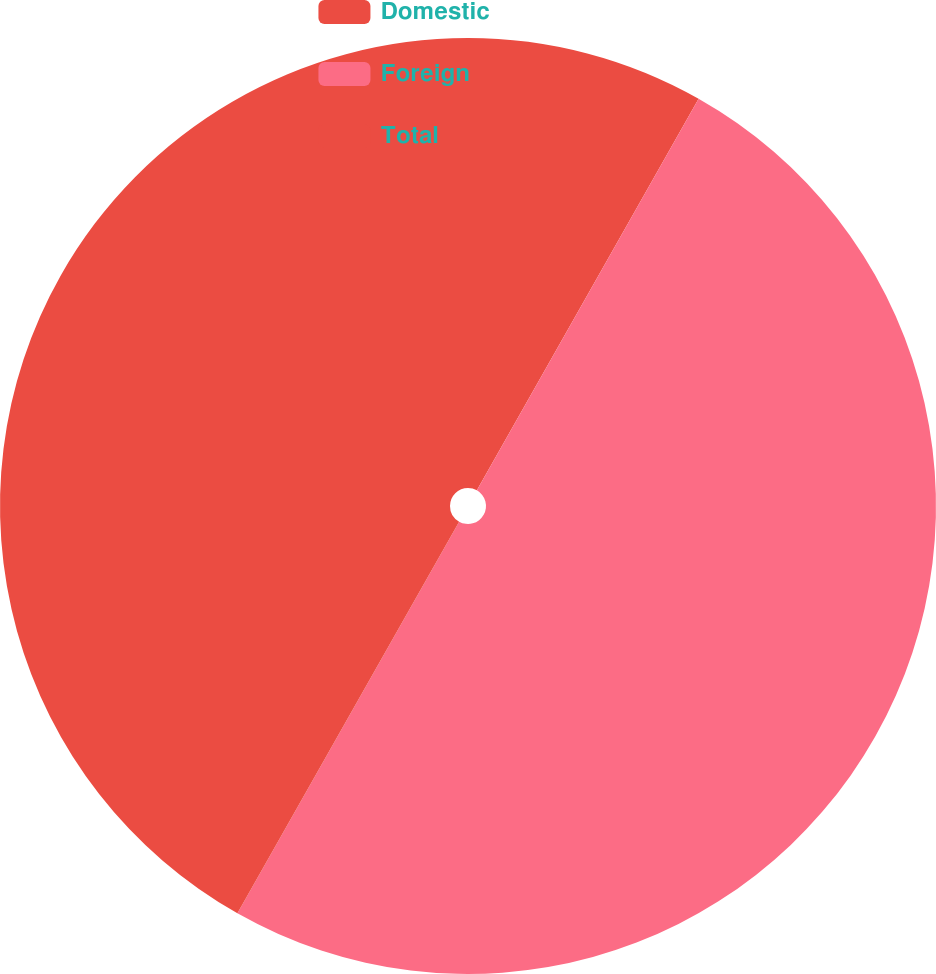Convert chart. <chart><loc_0><loc_0><loc_500><loc_500><pie_chart><fcel>Domestic<fcel>Foreign<fcel>Total<nl><fcel>8.2%<fcel>50.0%<fcel>41.8%<nl></chart> 